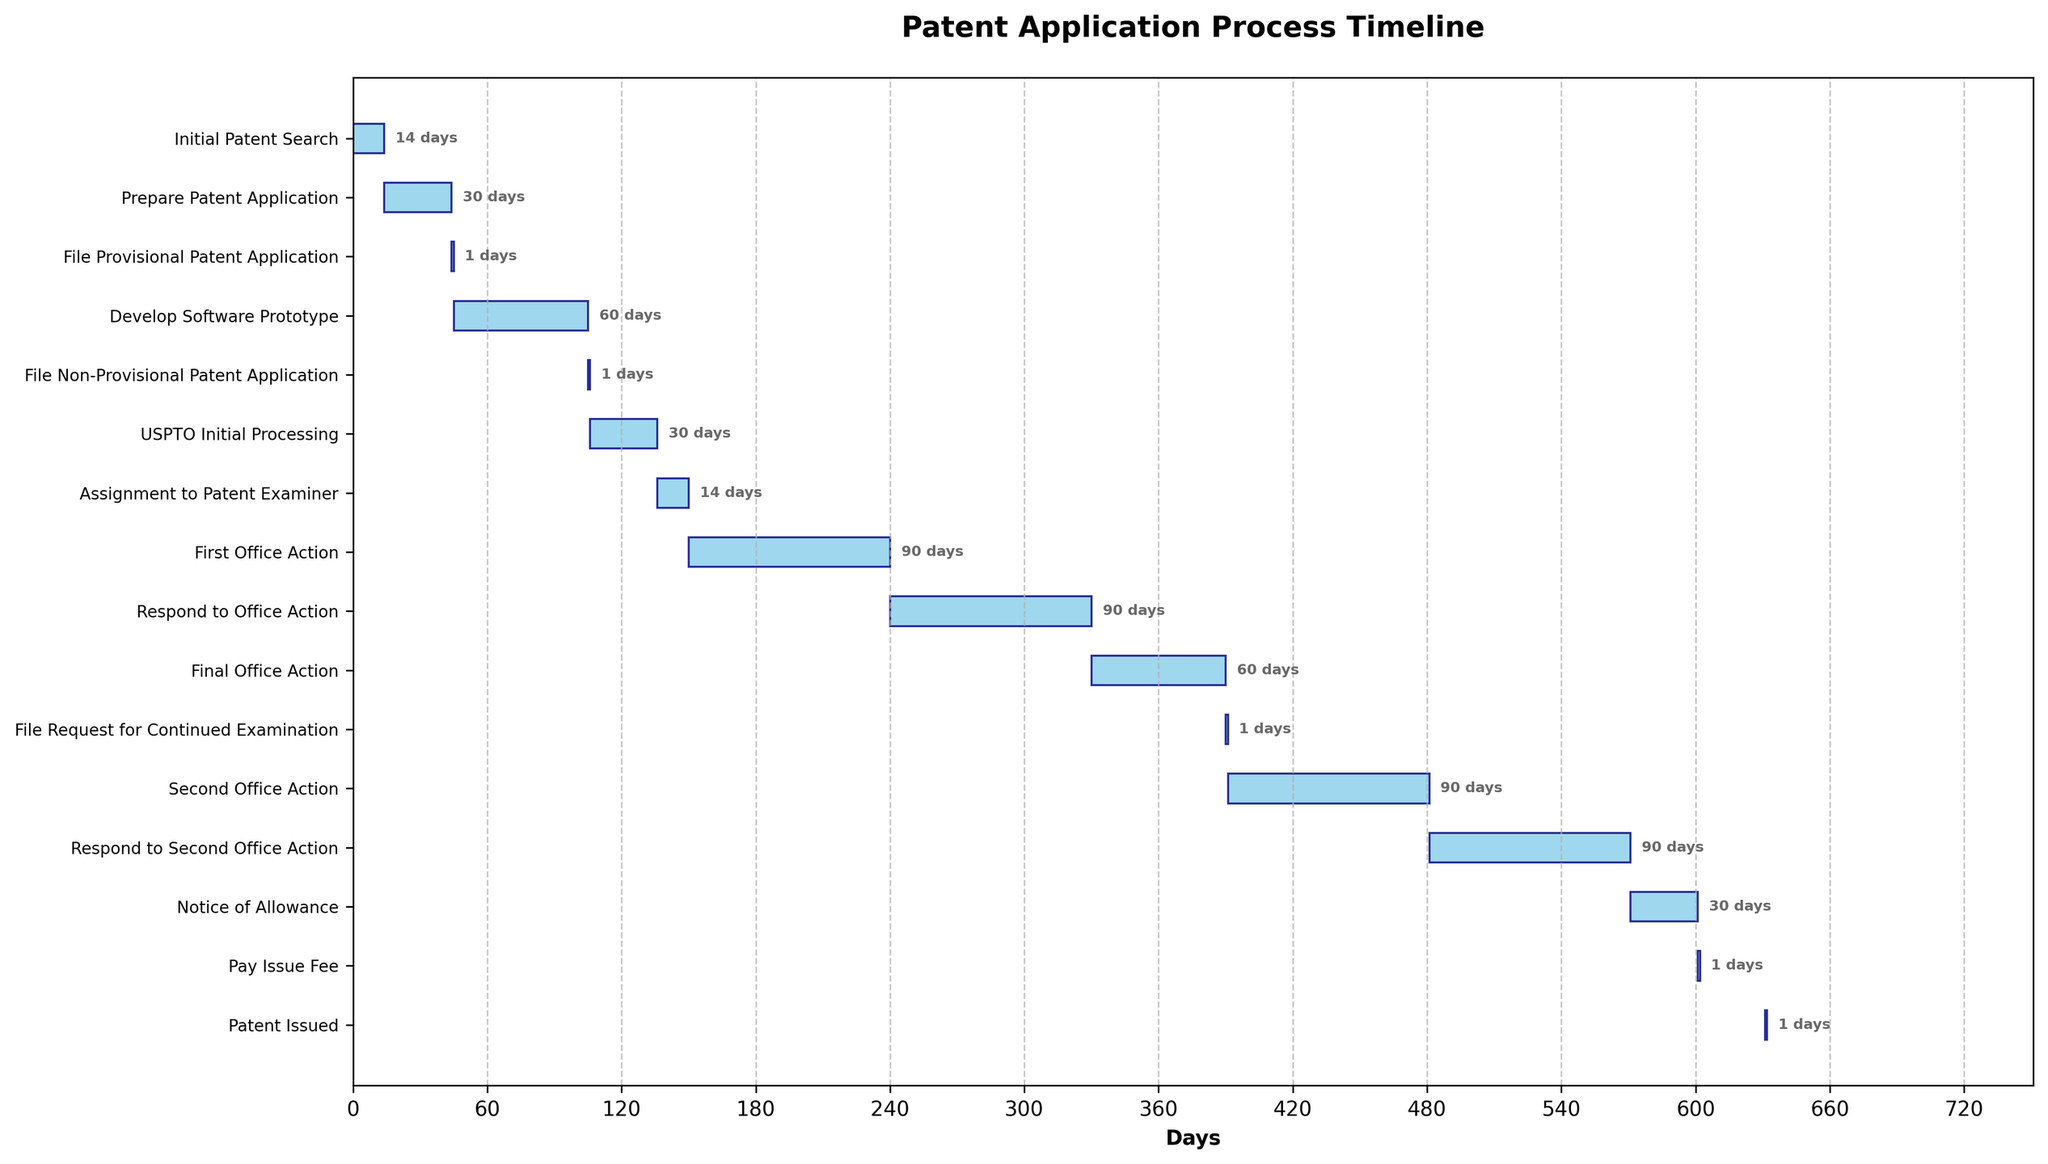what is the title of the chart? The title of the chart is located at the top center of the figure. It is shown in bolded text and provides an overview of what the Gantt chart depicts.
Answer: Patent Application Process Timeline How long does it take to develop the software prototype? To find the duration for developing the software prototype, look for the task "Develop Software Prototype" and check the corresponding duration value in days.
Answer: 60 days Which task takes the longest time to complete? To determine the longest task, compare the duration values of all tasks shown in the chart. Identify the task with the highest duration value.
Answer: Develop Software Prototype How many tasks have durations of 90 days? To count tasks with 90-day durations, look for tasks whose duration values are exactly 90 days in the chart.
Answer: 4 What is the total duration from the start of initial patent search to patent issued? Calculate the difference from the start of the "Initial Patent Search" to the end of the "Patent Issued" task. Add up the durations from the start of the first task to the end of the last one.
Answer: 632 days Which occurs first, the USPTO Initial Processing or the First Office Action? Compare the starting positions of "USPTO Initial Processing" and "First Office Action" to see which one appears earlier in the timeline.
Answer: USPTO Initial Processing What is the total time allocated for responding to office actions (first and second)? Add up the durations of the tasks "Respond to Office Action" and "Respond to Second Office Action".
Answer: 180 days How many tasks are there in total? Count the number of rows in the Gantt chart where each row represents a task.
Answer: 16 When does the assignment to patent examiner begin? Look for the task "Assignment to Patent Examiner" and note its starting day in the timeline.
Answer: Day 136 How much time is there between filing a non-provisional patent application and the assignment to a patent examiner? Calculate the difference between the starting days of "File Non-Provisional Patent Application" and "Assignment to Patent Examiner".
Answer: 135 days 